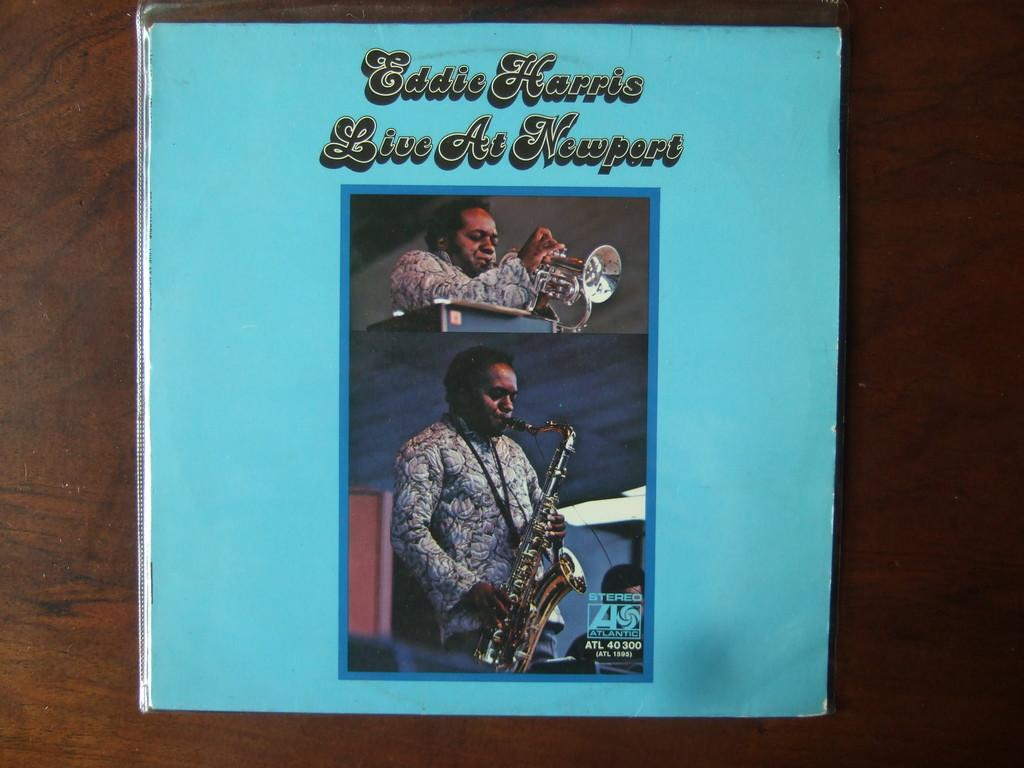<image>
Offer a succinct explanation of the picture presented. A music album is titled Eddie Harris Live at Newport. 